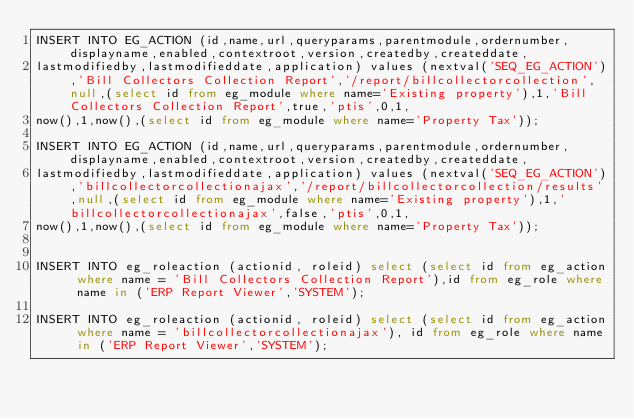Convert code to text. <code><loc_0><loc_0><loc_500><loc_500><_SQL_>INSERT INTO EG_ACTION (id,name,url,queryparams,parentmodule,ordernumber,displayname,enabled,contextroot,version,createdby,createddate,
lastmodifiedby,lastmodifieddate,application) values (nextval('SEQ_EG_ACTION'),'Bill Collectors Collection Report','/report/billcollectorcollection',null,(select id from eg_module where name='Existing property'),1,'Bill Collectors Collection Report',true,'ptis',0,1,
now(),1,now(),(select id from eg_module where name='Property Tax'));

INSERT INTO EG_ACTION (id,name,url,queryparams,parentmodule,ordernumber,displayname,enabled,contextroot,version,createdby,createddate,
lastmodifiedby,lastmodifieddate,application) values (nextval('SEQ_EG_ACTION'),'billcollectorcollectionajax','/report/billcollectorcollection/results',null,(select id from eg_module where name='Existing property'),1,'billcollectorcollectionajax',false,'ptis',0,1,
now(),1,now(),(select id from eg_module where name='Property Tax'));


INSERT INTO eg_roleaction (actionid, roleid) select (select id from eg_action where name = 'Bill Collectors Collection Report'),id from eg_role where name in ('ERP Report Viewer','SYSTEM');

INSERT INTO eg_roleaction (actionid, roleid) select (select id from eg_action where name = 'billcollectorcollectionajax'), id from eg_role where name in ('ERP Report Viewer','SYSTEM');


</code> 